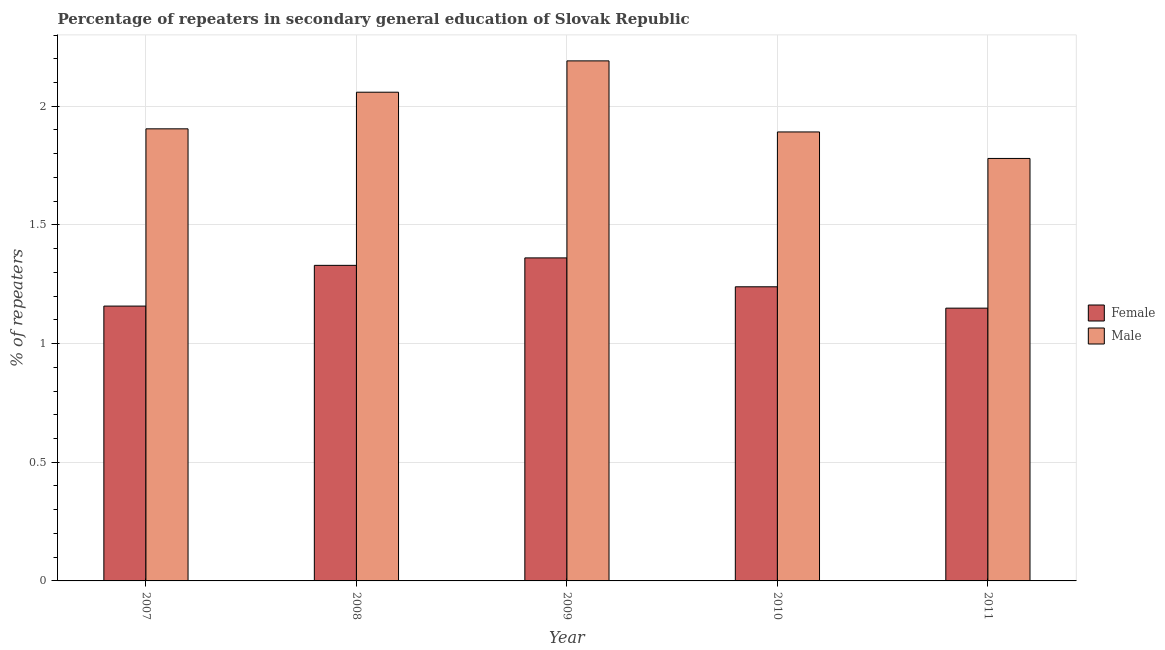Are the number of bars on each tick of the X-axis equal?
Ensure brevity in your answer.  Yes. How many bars are there on the 3rd tick from the left?
Provide a succinct answer. 2. How many bars are there on the 3rd tick from the right?
Your answer should be very brief. 2. What is the label of the 2nd group of bars from the left?
Give a very brief answer. 2008. In how many cases, is the number of bars for a given year not equal to the number of legend labels?
Provide a succinct answer. 0. What is the percentage of male repeaters in 2008?
Give a very brief answer. 2.06. Across all years, what is the maximum percentage of female repeaters?
Keep it short and to the point. 1.36. Across all years, what is the minimum percentage of female repeaters?
Ensure brevity in your answer.  1.15. In which year was the percentage of female repeaters maximum?
Ensure brevity in your answer.  2009. In which year was the percentage of male repeaters minimum?
Offer a terse response. 2011. What is the total percentage of female repeaters in the graph?
Your answer should be very brief. 6.24. What is the difference between the percentage of female repeaters in 2007 and that in 2009?
Your answer should be compact. -0.2. What is the difference between the percentage of male repeaters in 2011 and the percentage of female repeaters in 2010?
Your answer should be compact. -0.11. What is the average percentage of male repeaters per year?
Provide a succinct answer. 1.97. In the year 2009, what is the difference between the percentage of male repeaters and percentage of female repeaters?
Make the answer very short. 0. In how many years, is the percentage of male repeaters greater than 1.5 %?
Ensure brevity in your answer.  5. What is the ratio of the percentage of female repeaters in 2008 to that in 2011?
Provide a short and direct response. 1.16. Is the difference between the percentage of female repeaters in 2008 and 2009 greater than the difference between the percentage of male repeaters in 2008 and 2009?
Make the answer very short. No. What is the difference between the highest and the second highest percentage of female repeaters?
Offer a very short reply. 0.03. What is the difference between the highest and the lowest percentage of female repeaters?
Keep it short and to the point. 0.21. Is the sum of the percentage of male repeaters in 2008 and 2010 greater than the maximum percentage of female repeaters across all years?
Provide a short and direct response. Yes. What does the 2nd bar from the left in 2011 represents?
Provide a short and direct response. Male. How many bars are there?
Ensure brevity in your answer.  10. How many years are there in the graph?
Your answer should be very brief. 5. What is the difference between two consecutive major ticks on the Y-axis?
Keep it short and to the point. 0.5. Where does the legend appear in the graph?
Provide a short and direct response. Center right. How are the legend labels stacked?
Keep it short and to the point. Vertical. What is the title of the graph?
Provide a succinct answer. Percentage of repeaters in secondary general education of Slovak Republic. What is the label or title of the X-axis?
Make the answer very short. Year. What is the label or title of the Y-axis?
Offer a terse response. % of repeaters. What is the % of repeaters in Female in 2007?
Ensure brevity in your answer.  1.16. What is the % of repeaters in Male in 2007?
Provide a short and direct response. 1.9. What is the % of repeaters of Female in 2008?
Keep it short and to the point. 1.33. What is the % of repeaters in Male in 2008?
Your answer should be compact. 2.06. What is the % of repeaters of Female in 2009?
Offer a terse response. 1.36. What is the % of repeaters of Male in 2009?
Make the answer very short. 2.19. What is the % of repeaters in Female in 2010?
Your response must be concise. 1.24. What is the % of repeaters in Male in 2010?
Ensure brevity in your answer.  1.89. What is the % of repeaters in Female in 2011?
Give a very brief answer. 1.15. What is the % of repeaters of Male in 2011?
Make the answer very short. 1.78. Across all years, what is the maximum % of repeaters in Female?
Offer a terse response. 1.36. Across all years, what is the maximum % of repeaters of Male?
Provide a short and direct response. 2.19. Across all years, what is the minimum % of repeaters of Female?
Your response must be concise. 1.15. Across all years, what is the minimum % of repeaters in Male?
Provide a succinct answer. 1.78. What is the total % of repeaters in Female in the graph?
Offer a terse response. 6.24. What is the total % of repeaters of Male in the graph?
Your answer should be compact. 9.83. What is the difference between the % of repeaters in Female in 2007 and that in 2008?
Your answer should be very brief. -0.17. What is the difference between the % of repeaters in Male in 2007 and that in 2008?
Your response must be concise. -0.15. What is the difference between the % of repeaters of Female in 2007 and that in 2009?
Your response must be concise. -0.2. What is the difference between the % of repeaters of Male in 2007 and that in 2009?
Give a very brief answer. -0.29. What is the difference between the % of repeaters in Female in 2007 and that in 2010?
Your response must be concise. -0.08. What is the difference between the % of repeaters of Male in 2007 and that in 2010?
Make the answer very short. 0.01. What is the difference between the % of repeaters in Female in 2007 and that in 2011?
Provide a succinct answer. 0.01. What is the difference between the % of repeaters of Male in 2007 and that in 2011?
Your response must be concise. 0.12. What is the difference between the % of repeaters in Female in 2008 and that in 2009?
Your answer should be very brief. -0.03. What is the difference between the % of repeaters of Male in 2008 and that in 2009?
Keep it short and to the point. -0.13. What is the difference between the % of repeaters in Female in 2008 and that in 2010?
Your answer should be compact. 0.09. What is the difference between the % of repeaters in Male in 2008 and that in 2010?
Your answer should be very brief. 0.17. What is the difference between the % of repeaters of Female in 2008 and that in 2011?
Provide a succinct answer. 0.18. What is the difference between the % of repeaters of Male in 2008 and that in 2011?
Give a very brief answer. 0.28. What is the difference between the % of repeaters in Female in 2009 and that in 2010?
Provide a succinct answer. 0.12. What is the difference between the % of repeaters in Male in 2009 and that in 2010?
Ensure brevity in your answer.  0.3. What is the difference between the % of repeaters in Female in 2009 and that in 2011?
Offer a very short reply. 0.21. What is the difference between the % of repeaters in Male in 2009 and that in 2011?
Your response must be concise. 0.41. What is the difference between the % of repeaters in Female in 2010 and that in 2011?
Make the answer very short. 0.09. What is the difference between the % of repeaters of Male in 2010 and that in 2011?
Your answer should be compact. 0.11. What is the difference between the % of repeaters of Female in 2007 and the % of repeaters of Male in 2008?
Your response must be concise. -0.9. What is the difference between the % of repeaters in Female in 2007 and the % of repeaters in Male in 2009?
Your answer should be compact. -1.03. What is the difference between the % of repeaters of Female in 2007 and the % of repeaters of Male in 2010?
Keep it short and to the point. -0.73. What is the difference between the % of repeaters of Female in 2007 and the % of repeaters of Male in 2011?
Provide a short and direct response. -0.62. What is the difference between the % of repeaters of Female in 2008 and the % of repeaters of Male in 2009?
Give a very brief answer. -0.86. What is the difference between the % of repeaters in Female in 2008 and the % of repeaters in Male in 2010?
Offer a terse response. -0.56. What is the difference between the % of repeaters of Female in 2008 and the % of repeaters of Male in 2011?
Your response must be concise. -0.45. What is the difference between the % of repeaters of Female in 2009 and the % of repeaters of Male in 2010?
Your answer should be very brief. -0.53. What is the difference between the % of repeaters of Female in 2009 and the % of repeaters of Male in 2011?
Ensure brevity in your answer.  -0.42. What is the difference between the % of repeaters in Female in 2010 and the % of repeaters in Male in 2011?
Offer a very short reply. -0.54. What is the average % of repeaters in Female per year?
Your answer should be very brief. 1.25. What is the average % of repeaters in Male per year?
Offer a terse response. 1.97. In the year 2007, what is the difference between the % of repeaters of Female and % of repeaters of Male?
Provide a short and direct response. -0.75. In the year 2008, what is the difference between the % of repeaters in Female and % of repeaters in Male?
Ensure brevity in your answer.  -0.73. In the year 2009, what is the difference between the % of repeaters in Female and % of repeaters in Male?
Make the answer very short. -0.83. In the year 2010, what is the difference between the % of repeaters of Female and % of repeaters of Male?
Your answer should be compact. -0.65. In the year 2011, what is the difference between the % of repeaters of Female and % of repeaters of Male?
Provide a short and direct response. -0.63. What is the ratio of the % of repeaters in Female in 2007 to that in 2008?
Keep it short and to the point. 0.87. What is the ratio of the % of repeaters in Male in 2007 to that in 2008?
Offer a terse response. 0.93. What is the ratio of the % of repeaters of Female in 2007 to that in 2009?
Your answer should be compact. 0.85. What is the ratio of the % of repeaters of Male in 2007 to that in 2009?
Your answer should be compact. 0.87. What is the ratio of the % of repeaters in Female in 2007 to that in 2010?
Your response must be concise. 0.93. What is the ratio of the % of repeaters in Male in 2007 to that in 2010?
Provide a succinct answer. 1.01. What is the ratio of the % of repeaters of Female in 2007 to that in 2011?
Keep it short and to the point. 1.01. What is the ratio of the % of repeaters in Male in 2007 to that in 2011?
Provide a succinct answer. 1.07. What is the ratio of the % of repeaters in Female in 2008 to that in 2009?
Ensure brevity in your answer.  0.98. What is the ratio of the % of repeaters of Male in 2008 to that in 2009?
Your answer should be compact. 0.94. What is the ratio of the % of repeaters in Female in 2008 to that in 2010?
Your response must be concise. 1.07. What is the ratio of the % of repeaters in Male in 2008 to that in 2010?
Provide a short and direct response. 1.09. What is the ratio of the % of repeaters of Female in 2008 to that in 2011?
Provide a short and direct response. 1.16. What is the ratio of the % of repeaters in Male in 2008 to that in 2011?
Offer a very short reply. 1.16. What is the ratio of the % of repeaters in Female in 2009 to that in 2010?
Provide a short and direct response. 1.1. What is the ratio of the % of repeaters in Male in 2009 to that in 2010?
Offer a very short reply. 1.16. What is the ratio of the % of repeaters of Female in 2009 to that in 2011?
Your answer should be very brief. 1.18. What is the ratio of the % of repeaters in Male in 2009 to that in 2011?
Give a very brief answer. 1.23. What is the ratio of the % of repeaters in Female in 2010 to that in 2011?
Ensure brevity in your answer.  1.08. What is the ratio of the % of repeaters of Male in 2010 to that in 2011?
Make the answer very short. 1.06. What is the difference between the highest and the second highest % of repeaters in Female?
Provide a succinct answer. 0.03. What is the difference between the highest and the second highest % of repeaters in Male?
Offer a terse response. 0.13. What is the difference between the highest and the lowest % of repeaters of Female?
Provide a succinct answer. 0.21. What is the difference between the highest and the lowest % of repeaters in Male?
Offer a very short reply. 0.41. 